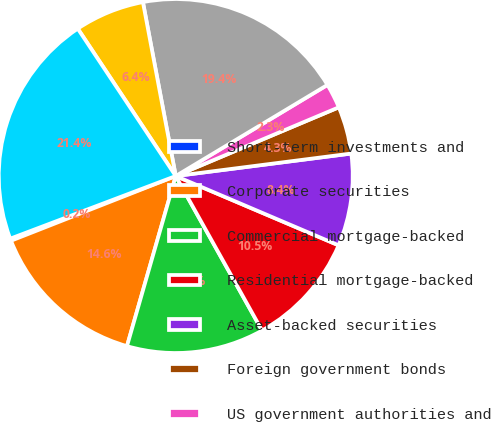Convert chart. <chart><loc_0><loc_0><loc_500><loc_500><pie_chart><fcel>Short-term investments and<fcel>Corporate securities<fcel>Commercial mortgage-backed<fcel>Residential mortgage-backed<fcel>Asset-backed securities<fcel>Foreign government bonds<fcel>US government authorities and<fcel>Total fixed maturities<fcel>Equity securities<fcel>Total trading account assets<nl><fcel>0.2%<fcel>14.6%<fcel>12.55%<fcel>10.49%<fcel>8.43%<fcel>4.32%<fcel>2.26%<fcel>19.36%<fcel>6.37%<fcel>21.42%<nl></chart> 